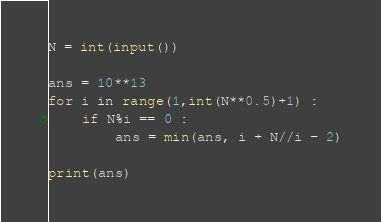<code> <loc_0><loc_0><loc_500><loc_500><_Python_>N = int(input())

ans = 10**13
for i in range(1,int(N**0.5)+1) :
    if N%i == 0 :
        ans = min(ans, i + N//i - 2)

print(ans)
</code> 